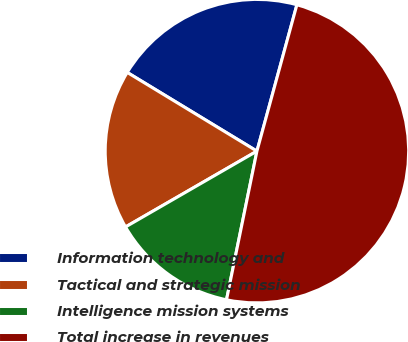<chart> <loc_0><loc_0><loc_500><loc_500><pie_chart><fcel>Information technology and<fcel>Tactical and strategic mission<fcel>Intelligence mission systems<fcel>Total increase in revenues<nl><fcel>20.56%<fcel>17.01%<fcel>13.46%<fcel>48.97%<nl></chart> 